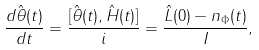Convert formula to latex. <formula><loc_0><loc_0><loc_500><loc_500>\frac { d \hat { \theta } ( t ) } { d t } = \frac { [ \hat { \theta } ( t ) , \hat { H } ( t ) ] } { i } = \frac { \hat { L } ( 0 ) - n _ { \Phi } ( t ) } { I } ,</formula> 